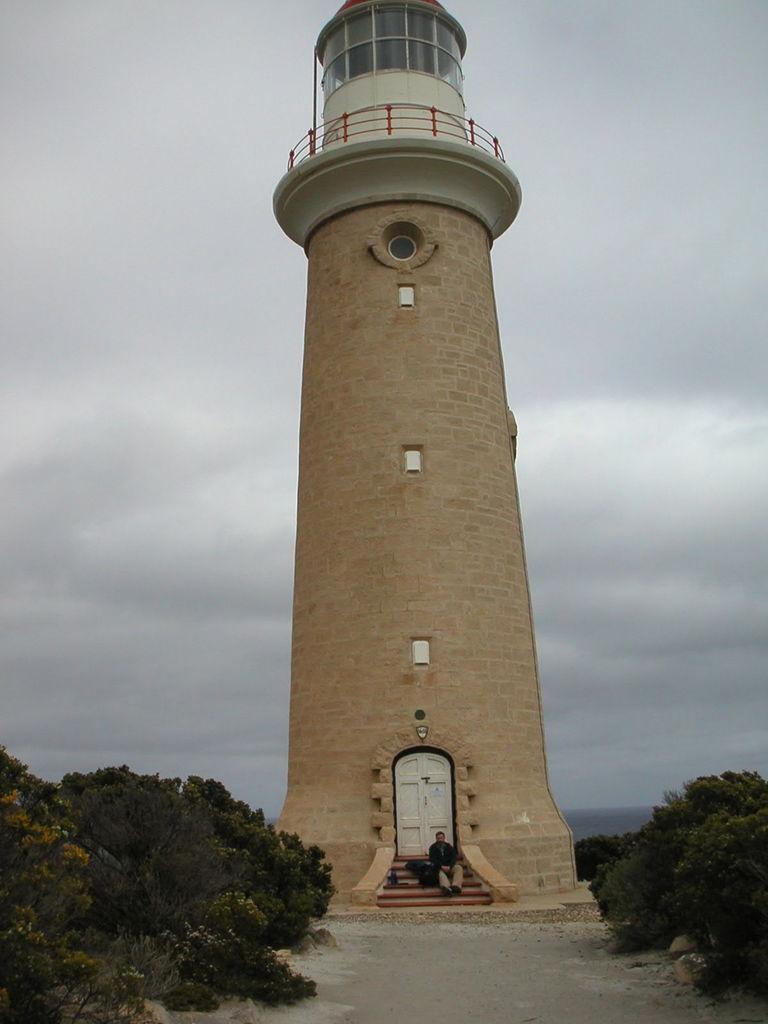Could you give a brief overview of what you see in this image? In this picture we can see a brown color light house. In the front there is a man sitting on the steps and white door in the back. On both the sides we can see some trees. 